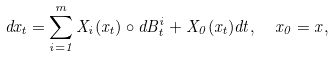<formula> <loc_0><loc_0><loc_500><loc_500>d x _ { t } = \sum _ { i = 1 } ^ { m } X _ { i } ( x _ { t } ) \circ d B ^ { i } _ { t } + X _ { 0 } ( x _ { t } ) d t , \ \ x _ { 0 } = x ,</formula> 